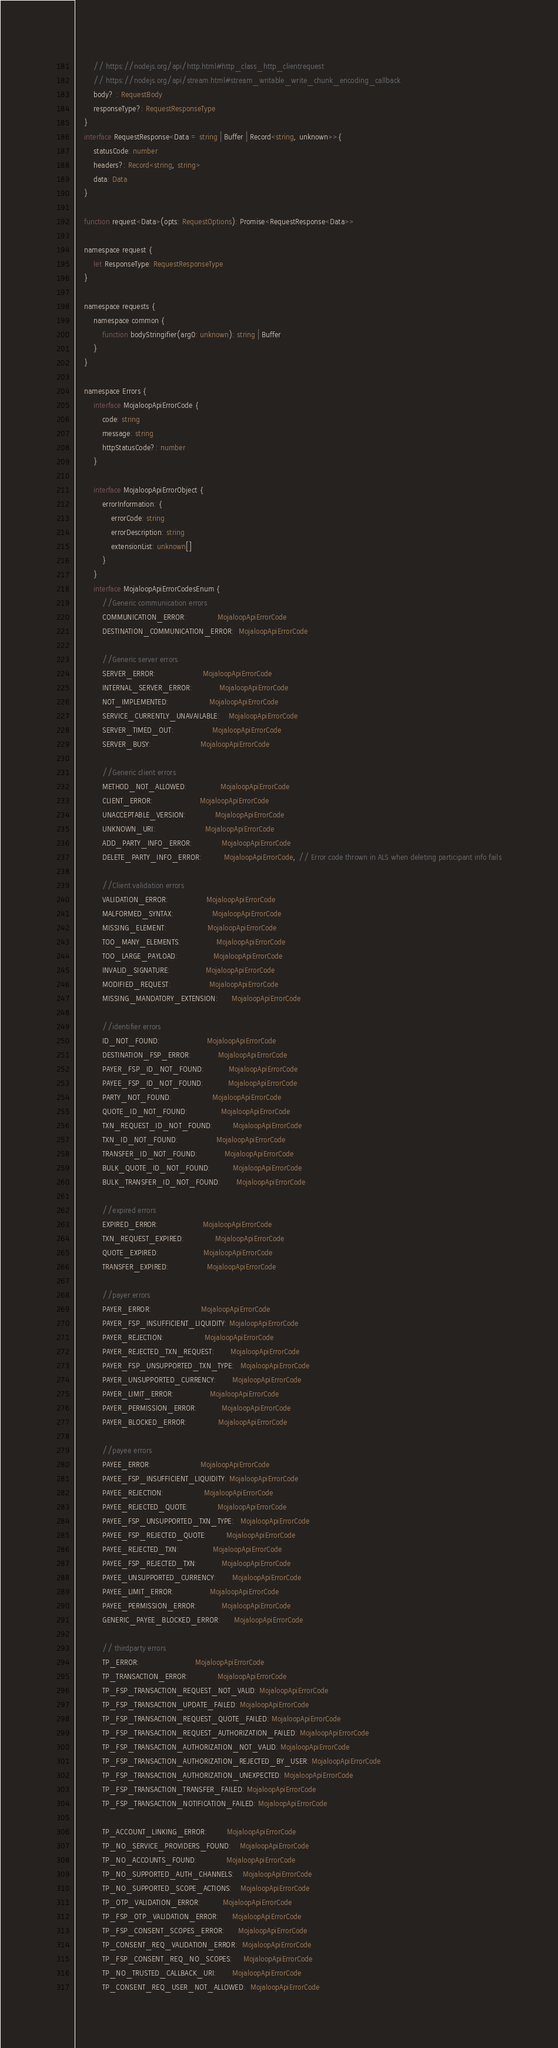Convert code to text. <code><loc_0><loc_0><loc_500><loc_500><_TypeScript_>        // https://nodejs.org/api/http.html#http_class_http_clientrequest
        // https://nodejs.org/api/stream.html#stream_writable_write_chunk_encoding_callback
        body? : RequestBody
        responseType?: RequestResponseType
    }
    interface RequestResponse<Data = string | Buffer | Record<string, unknown>>{
        statusCode: number
        headers?: Record<string, string>
        data: Data
    }

    function request<Data>(opts: RequestOptions): Promise<RequestResponse<Data>>

    namespace request {
        let ResponseType: RequestResponseType
    }

    namespace requests {
        namespace common {
            function bodyStringifier(arg0: unknown): string | Buffer
        }
    }

    namespace Errors {
        interface MojaloopApiErrorCode {
            code: string
            message: string
            httpStatusCode?: number
        }

        interface MojaloopApiErrorObject {
            errorInformation: {
                errorCode: string
                errorDescription: string
                extensionList: unknown[]
            }
        }
        interface MojaloopApiErrorCodesEnum {
            //Generic communication errors
            COMMUNICATION_ERROR:              MojaloopApiErrorCode
            DESTINATION_COMMUNICATION_ERROR:  MojaloopApiErrorCode

            //Generic server errors
            SERVER_ERROR:                     MojaloopApiErrorCode
            INTERNAL_SERVER_ERROR:            MojaloopApiErrorCode
            NOT_IMPLEMENTED:                  MojaloopApiErrorCode
            SERVICE_CURRENTLY_UNAVAILABLE:    MojaloopApiErrorCode
            SERVER_TIMED_OUT:                 MojaloopApiErrorCode
            SERVER_BUSY:                      MojaloopApiErrorCode

            //Generic client errors
            METHOD_NOT_ALLOWED:               MojaloopApiErrorCode
            CLIENT_ERROR:                     MojaloopApiErrorCode
            UNACCEPTABLE_VERSION:             MojaloopApiErrorCode
            UNKNOWN_URI:                      MojaloopApiErrorCode
            ADD_PARTY_INFO_ERROR:             MojaloopApiErrorCode
            DELETE_PARTY_INFO_ERROR:          MojaloopApiErrorCode, // Error code thrown in ALS when deleting participant info fails

            //Client validation errors
            VALIDATION_ERROR:                 MojaloopApiErrorCode
            MALFORMED_SYNTAX:                 MojaloopApiErrorCode
            MISSING_ELEMENT:                  MojaloopApiErrorCode
            TOO_MANY_ELEMENTS:                MojaloopApiErrorCode
            TOO_LARGE_PAYLOAD:                MojaloopApiErrorCode
            INVALID_SIGNATURE:                MojaloopApiErrorCode
            MODIFIED_REQUEST:                 MojaloopApiErrorCode
            MISSING_MANDATORY_EXTENSION:      MojaloopApiErrorCode

            //identifier errors
            ID_NOT_FOUND:                     MojaloopApiErrorCode
            DESTINATION_FSP_ERROR:            MojaloopApiErrorCode
            PAYER_FSP_ID_NOT_FOUND:           MojaloopApiErrorCode
            PAYEE_FSP_ID_NOT_FOUND:           MojaloopApiErrorCode
            PARTY_NOT_FOUND:                  MojaloopApiErrorCode
            QUOTE_ID_NOT_FOUND:               MojaloopApiErrorCode
            TXN_REQUEST_ID_NOT_FOUND:         MojaloopApiErrorCode
            TXN_ID_NOT_FOUND:                 MojaloopApiErrorCode
            TRANSFER_ID_NOT_FOUND:            MojaloopApiErrorCode
            BULK_QUOTE_ID_NOT_FOUND:          MojaloopApiErrorCode
            BULK_TRANSFER_ID_NOT_FOUND:       MojaloopApiErrorCode

            //expired errors
            EXPIRED_ERROR:                    MojaloopApiErrorCode
            TXN_REQUEST_EXPIRED:              MojaloopApiErrorCode
            QUOTE_EXPIRED:                    MojaloopApiErrorCode
            TRANSFER_EXPIRED:                 MojaloopApiErrorCode

            //payer errors
            PAYER_ERROR:                      MojaloopApiErrorCode
            PAYER_FSP_INSUFFICIENT_LIQUIDITY: MojaloopApiErrorCode
            PAYER_REJECTION:                  MojaloopApiErrorCode
            PAYER_REJECTED_TXN_REQUEST:       MojaloopApiErrorCode
            PAYER_FSP_UNSUPPORTED_TXN_TYPE:   MojaloopApiErrorCode
            PAYER_UNSUPPORTED_CURRENCY:       MojaloopApiErrorCode
            PAYER_LIMIT_ERROR:                MojaloopApiErrorCode
            PAYER_PERMISSION_ERROR:           MojaloopApiErrorCode
            PAYER_BLOCKED_ERROR:              MojaloopApiErrorCode

            //payee errors
            PAYEE_ERROR:                      MojaloopApiErrorCode
            PAYEE_FSP_INSUFFICIENT_LIQUIDITY: MojaloopApiErrorCode
            PAYEE_REJECTION:                  MojaloopApiErrorCode
            PAYEE_REJECTED_QUOTE:             MojaloopApiErrorCode
            PAYEE_FSP_UNSUPPORTED_TXN_TYPE:   MojaloopApiErrorCode
            PAYEE_FSP_REJECTED_QUOTE:         MojaloopApiErrorCode
            PAYEE_REJECTED_TXN:               MojaloopApiErrorCode
            PAYEE_FSP_REJECTED_TXN:           MojaloopApiErrorCode
            PAYEE_UNSUPPORTED_CURRENCY:       MojaloopApiErrorCode
            PAYEE_LIMIT_ERROR:                MojaloopApiErrorCode
            PAYEE_PERMISSION_ERROR:           MojaloopApiErrorCode
            GENERIC_PAYEE_BLOCKED_ERROR:      MojaloopApiErrorCode

            // thirdparty errors
            TP_ERROR:                         MojaloopApiErrorCode
            TP_TRANSACTION_ERROR:             MojaloopApiErrorCode
            TP_FSP_TRANSACTION_REQUEST_NOT_VALID: MojaloopApiErrorCode
            TP_FSP_TRANSACTION_UPDATE_FAILED: MojaloopApiErrorCode
            TP_FSP_TRANSACTION_REQUEST_QUOTE_FAILED: MojaloopApiErrorCode
            TP_FSP_TRANSACTION_REQUEST_AUTHORIZATION_FAILED: MojaloopApiErrorCode
            TP_FSP_TRANSACTION_AUTHORIZATION_NOT_VALID: MojaloopApiErrorCode
            TP_FSP_TRANSACTION_AUTHORIZATION_REJECTED_BY_USER: MojaloopApiErrorCode
            TP_FSP_TRANSACTION_AUTHORIZATION_UNEXPECTED: MojaloopApiErrorCode
            TP_FSP_TRANSACTION_TRANSFER_FAILED: MojaloopApiErrorCode
            TP_FSP_TRANSACTION_NOTIFICATION_FAILED: MojaloopApiErrorCode

            TP_ACCOUNT_LINKING_ERROR:         MojaloopApiErrorCode
            TP_NO_SERVICE_PROVIDERS_FOUND:    MojaloopApiErrorCode
            TP_NO_ACCOUNTS_FOUND:             MojaloopApiErrorCode
            TP_NO_SUPPORTED_AUTH_CHANNELS:    MojaloopApiErrorCode
            TP_NO_SUPPORTED_SCOPE_ACTIONS:    MojaloopApiErrorCode
            TP_OTP_VALIDATION_ERROR:          MojaloopApiErrorCode
            TP_FSP_OTP_VALIDATION_ERROR:      MojaloopApiErrorCode
            TP_FSP_CONSENT_SCOPES_ERROR:      MojaloopApiErrorCode
            TP_CONSENT_REQ_VALIDATION_ERROR:  MojaloopApiErrorCode
            TP_FSP_CONSENT_REQ_NO_SCOPES:     MojaloopApiErrorCode
            TP_NO_TRUSTED_CALLBACK_URI:       MojaloopApiErrorCode
            TP_CONSENT_REQ_USER_NOT_ALLOWED:  MojaloopApiErrorCode</code> 